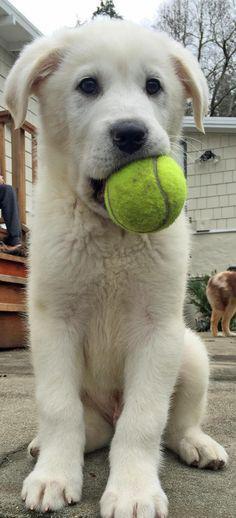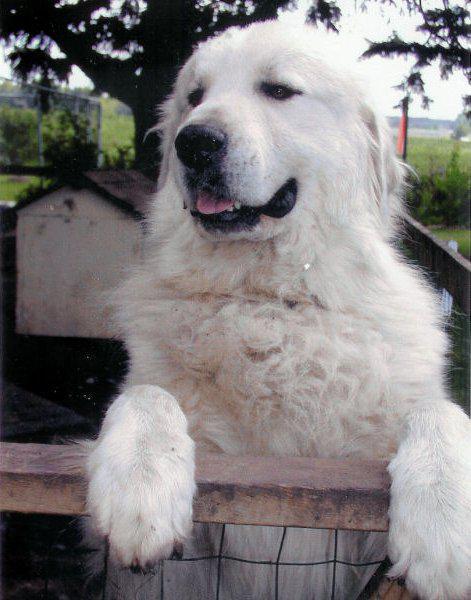The first image is the image on the left, the second image is the image on the right. For the images displayed, is the sentence "there are two dogs in the image pair" factually correct? Answer yes or no. Yes. The first image is the image on the left, the second image is the image on the right. Assess this claim about the two images: "One dog is sitting.". Correct or not? Answer yes or no. Yes. 